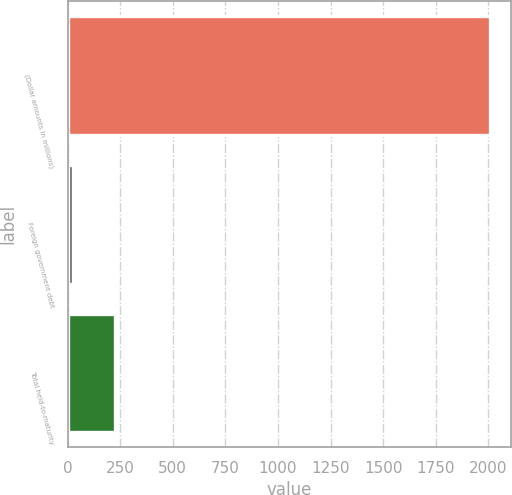<chart> <loc_0><loc_0><loc_500><loc_500><bar_chart><fcel>(Dollar amounts in millions)<fcel>Foreign government debt<fcel>Total held-to-maturity<nl><fcel>2009<fcel>28<fcel>226.1<nl></chart> 